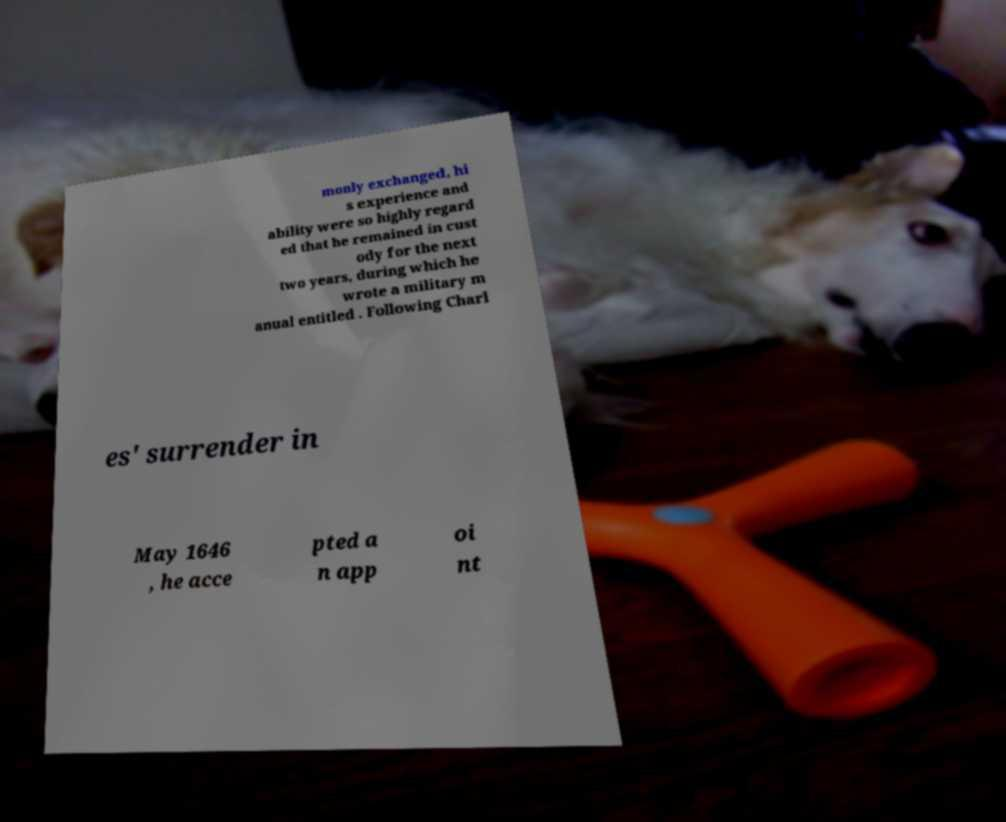I need the written content from this picture converted into text. Can you do that? monly exchanged, hi s experience and ability were so highly regard ed that he remained in cust ody for the next two years, during which he wrote a military m anual entitled . Following Charl es' surrender in May 1646 , he acce pted a n app oi nt 